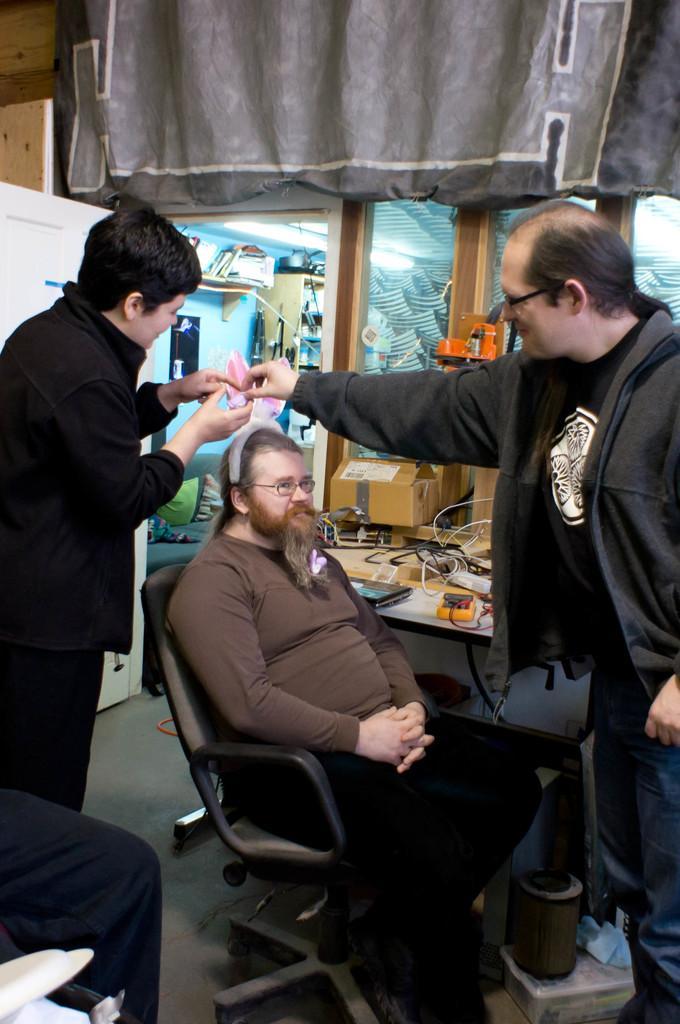How would you summarize this image in a sentence or two? On the left side, there is a person in black color dress, holding an object. On the right side, there is a person in gray color coat, holding an object, which is on the other person's hand. In between them, there is another person, sitting on a chair, near another person who is sitting on another chair. In the background, there is a table, on which, there are some objects, there are some objects on the shelf, near a poster on the wall, there is a curtain and other objects. 